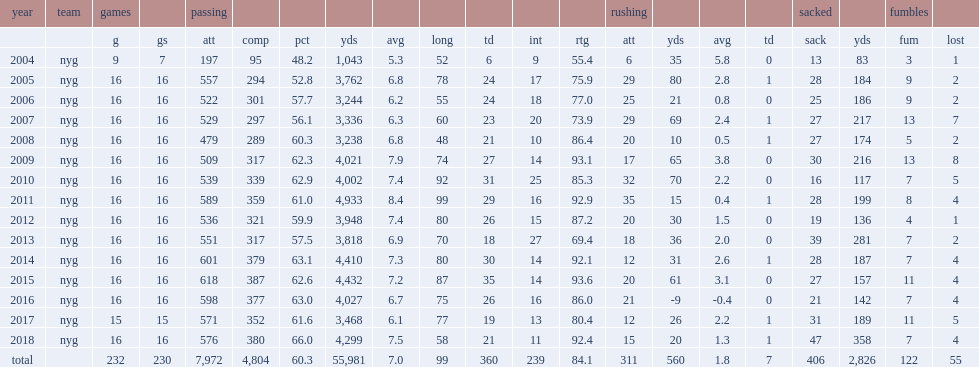How many yards did eli manning pass for, in the 2018 season? 4299.0. 